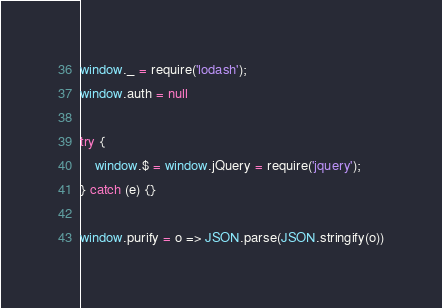<code> <loc_0><loc_0><loc_500><loc_500><_JavaScript_>
window._ = require('lodash');
window.auth = null

try {
    window.$ = window.jQuery = require('jquery');
} catch (e) {}

window.purify = o => JSON.parse(JSON.stringify(o))</code> 